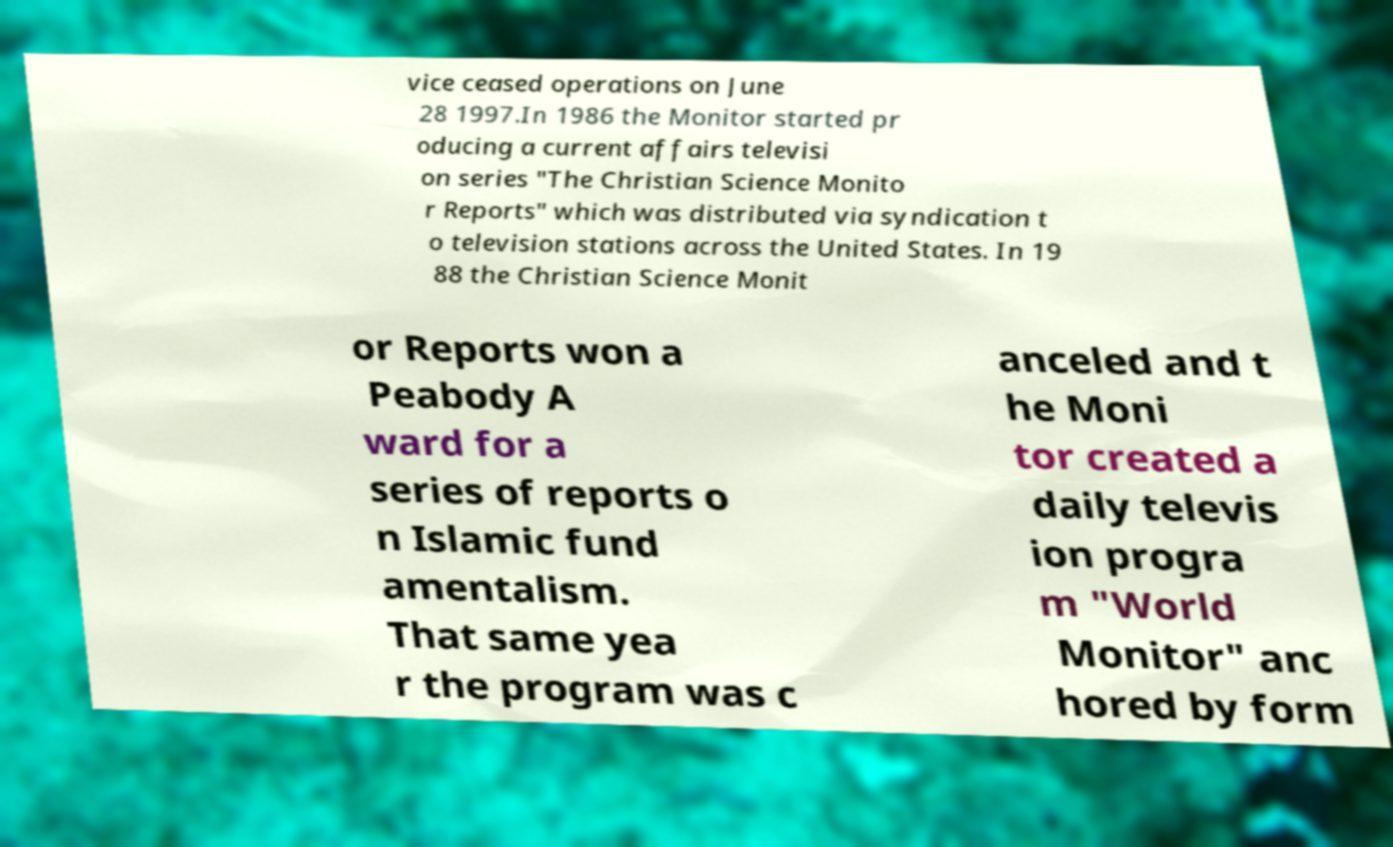Please read and relay the text visible in this image. What does it say? vice ceased operations on June 28 1997.In 1986 the Monitor started pr oducing a current affairs televisi on series "The Christian Science Monito r Reports" which was distributed via syndication t o television stations across the United States. In 19 88 the Christian Science Monit or Reports won a Peabody A ward for a series of reports o n Islamic fund amentalism. That same yea r the program was c anceled and t he Moni tor created a daily televis ion progra m "World Monitor" anc hored by form 